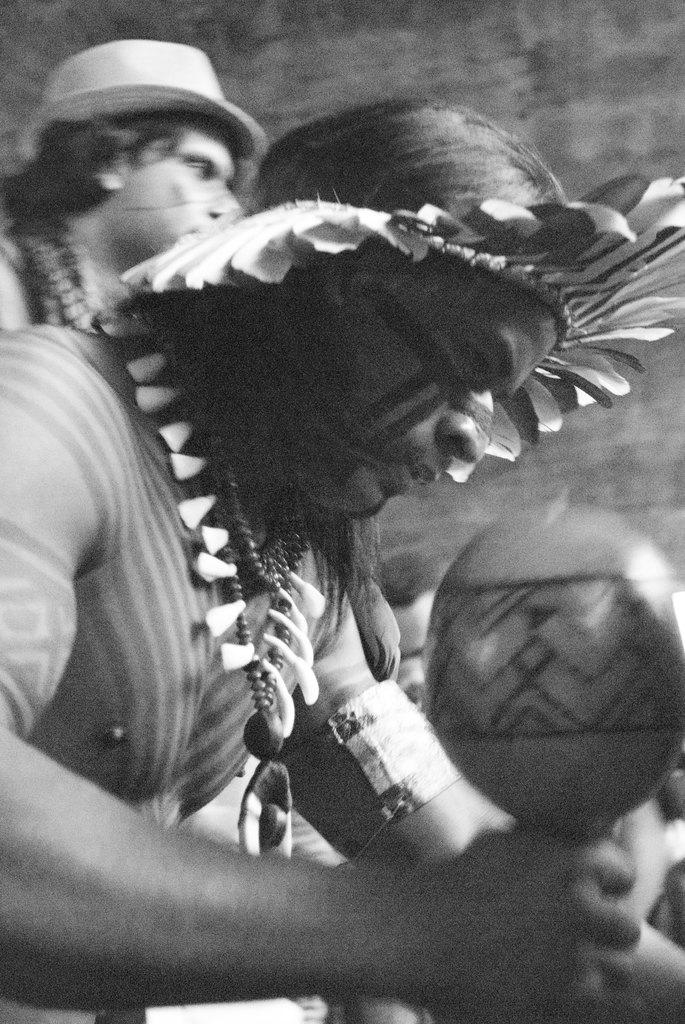Who are the people in the image? There are tribals in the image. What is the man holding in the image? A man is holding an object in the image. What can be seen in the background of the image? There is a wall in the background of the image. How many bikes are parked next to the wall in the image? There are no bikes present in the image; only tribals, a man holding an object, and a wall can be seen. 